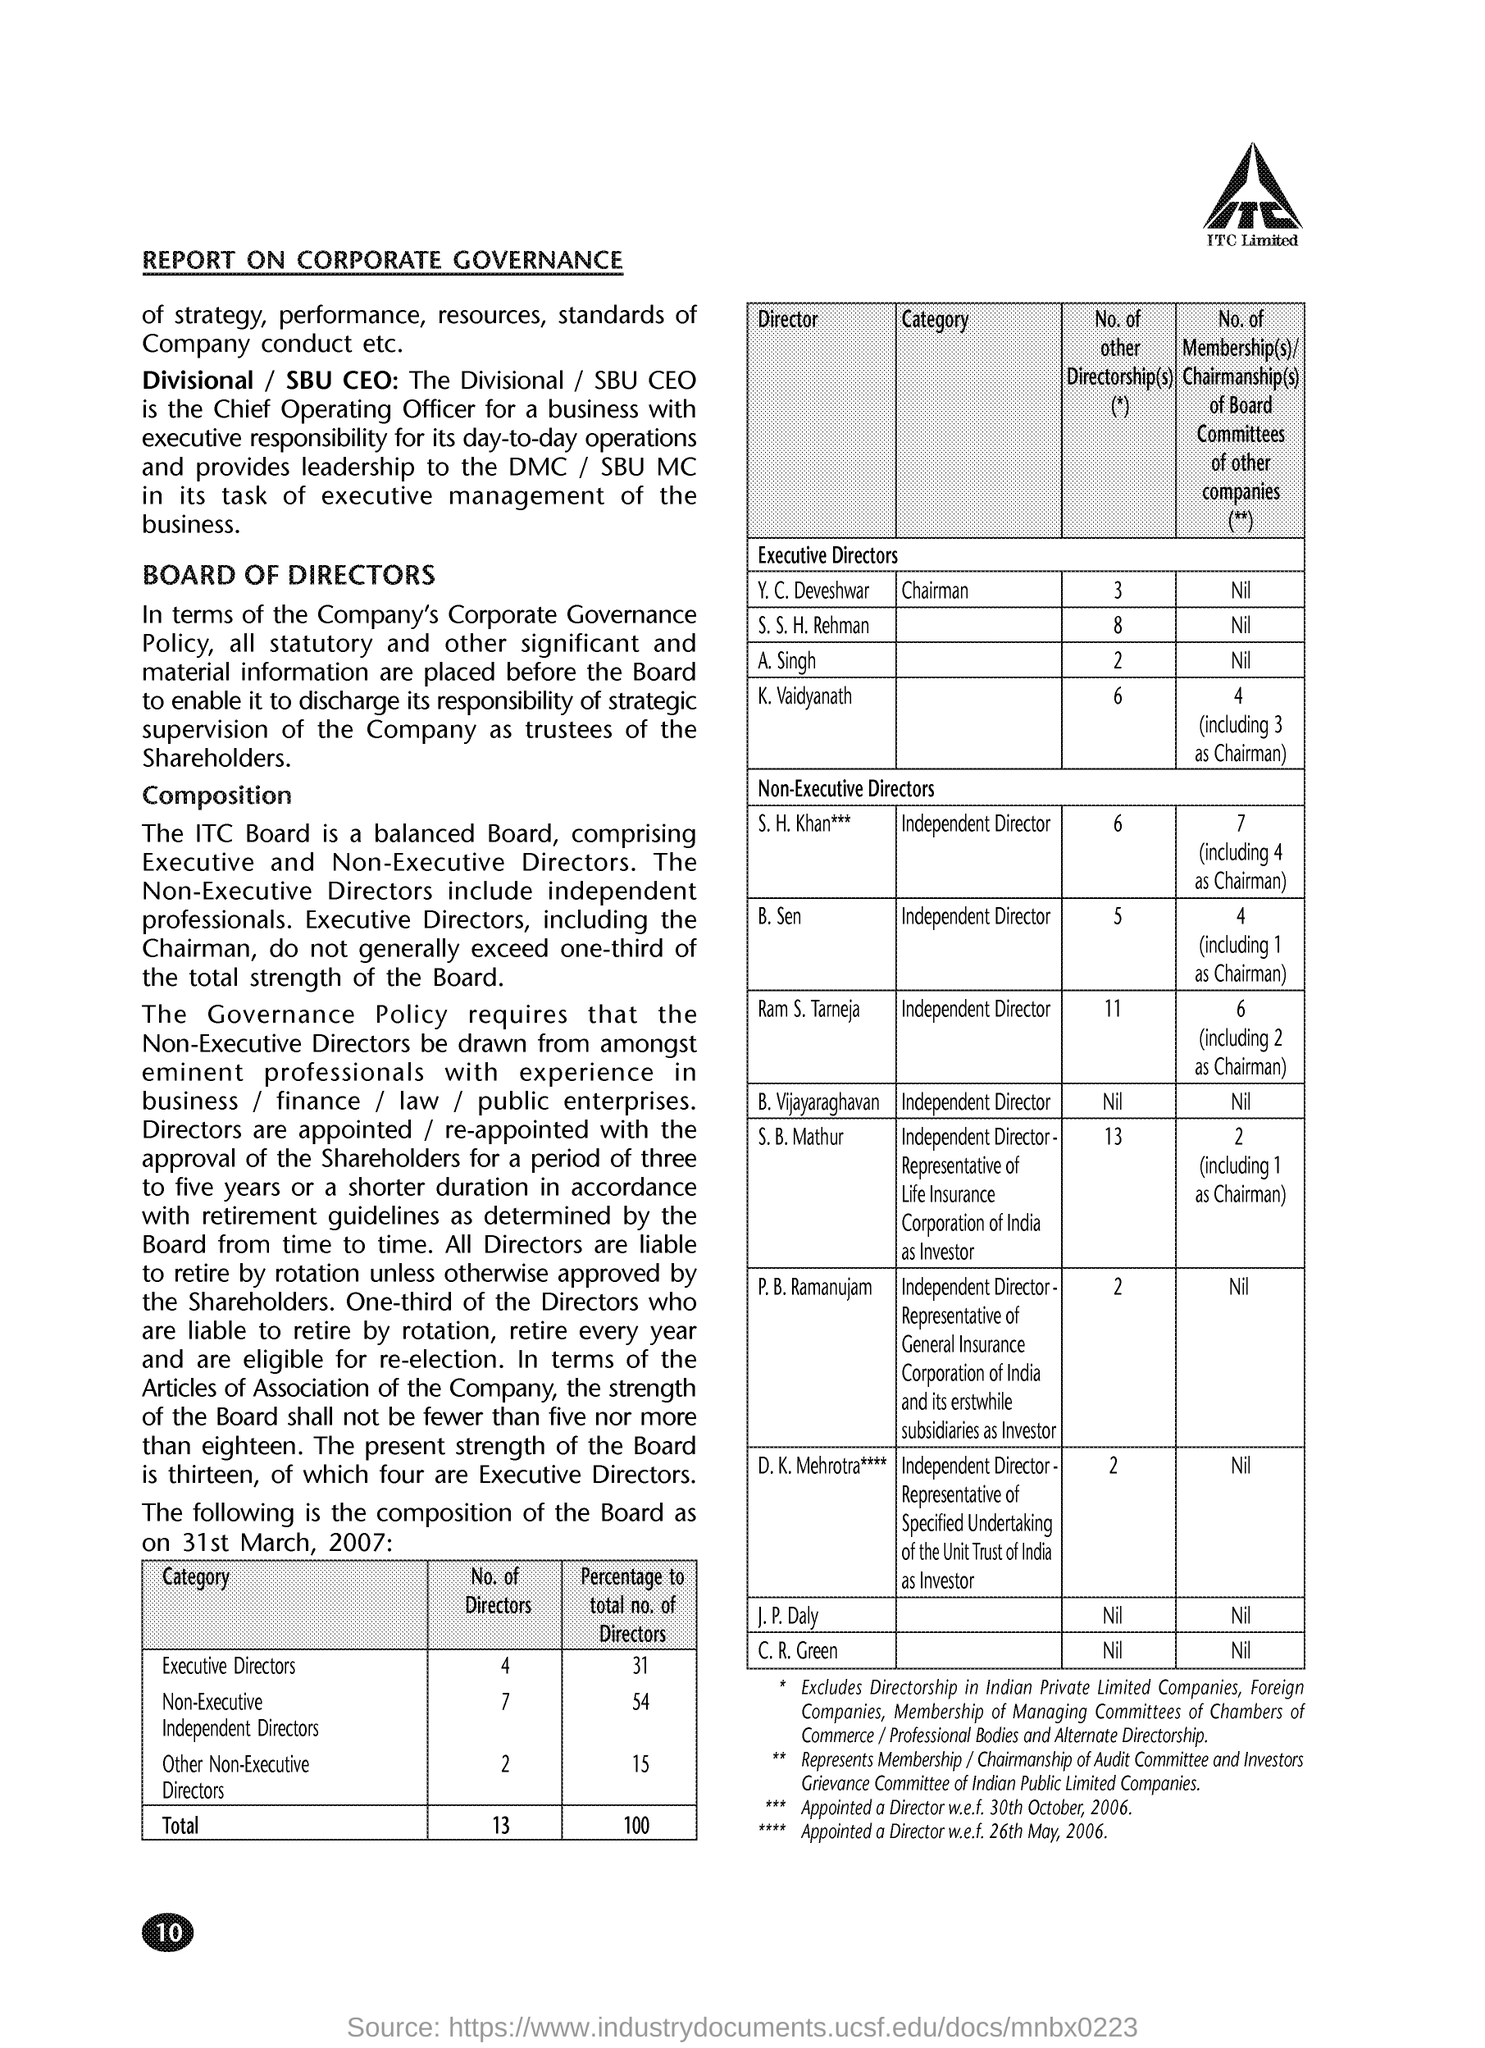What is the date on the document?
Your answer should be compact. 31st March, 2007. What are the Total No. of Directors?
Provide a short and direct response. 13. What is the Total Percentage to Total No. of Directors?
Your response must be concise. 100. What is the No. of Executive Directors?
Your answer should be very brief. 4. What is the No. of Non-Executive Independent Directors?
Keep it short and to the point. 7. What is the No. of Other Non-Executive Directors?
Make the answer very short. 2. 